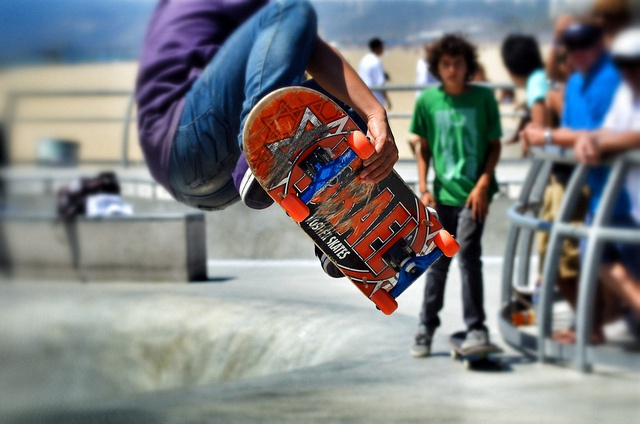Describe the objects in this image and their specific colors. I can see people in gray, black, navy, and blue tones, skateboard in gray, black, brown, and maroon tones, people in gray, black, darkgreen, and teal tones, people in gray, blue, black, and navy tones, and people in gray, black, brown, and lightblue tones in this image. 